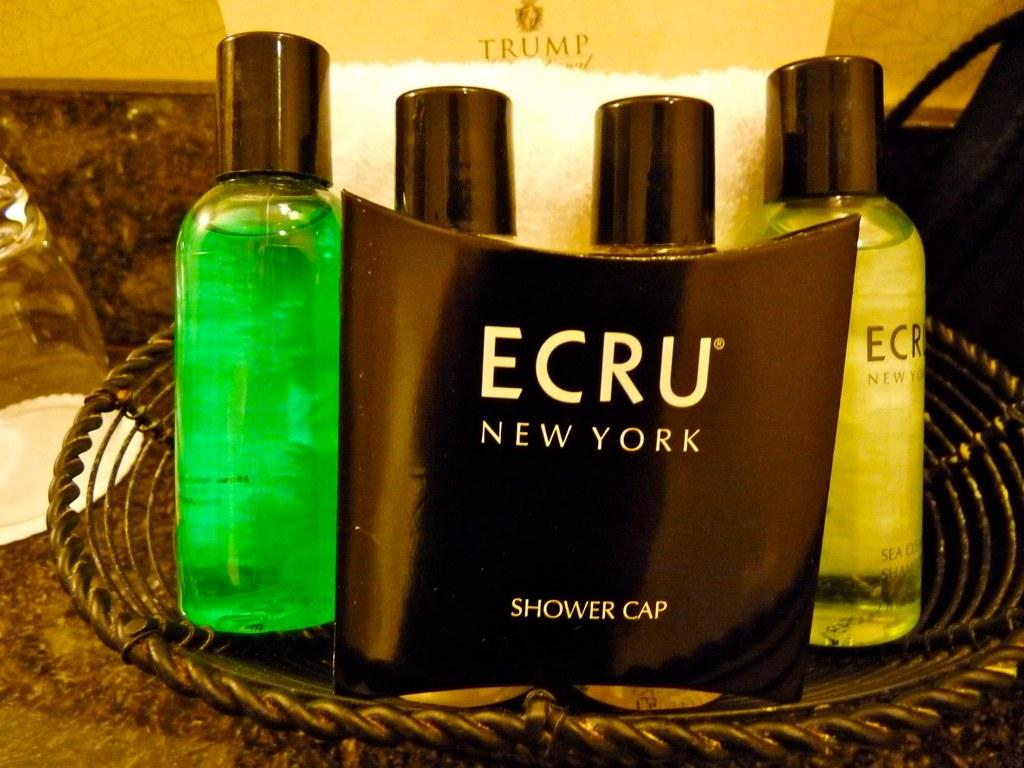<image>
Share a concise interpretation of the image provided. Shower collection of body washes and shower cap by Ecru of New York 